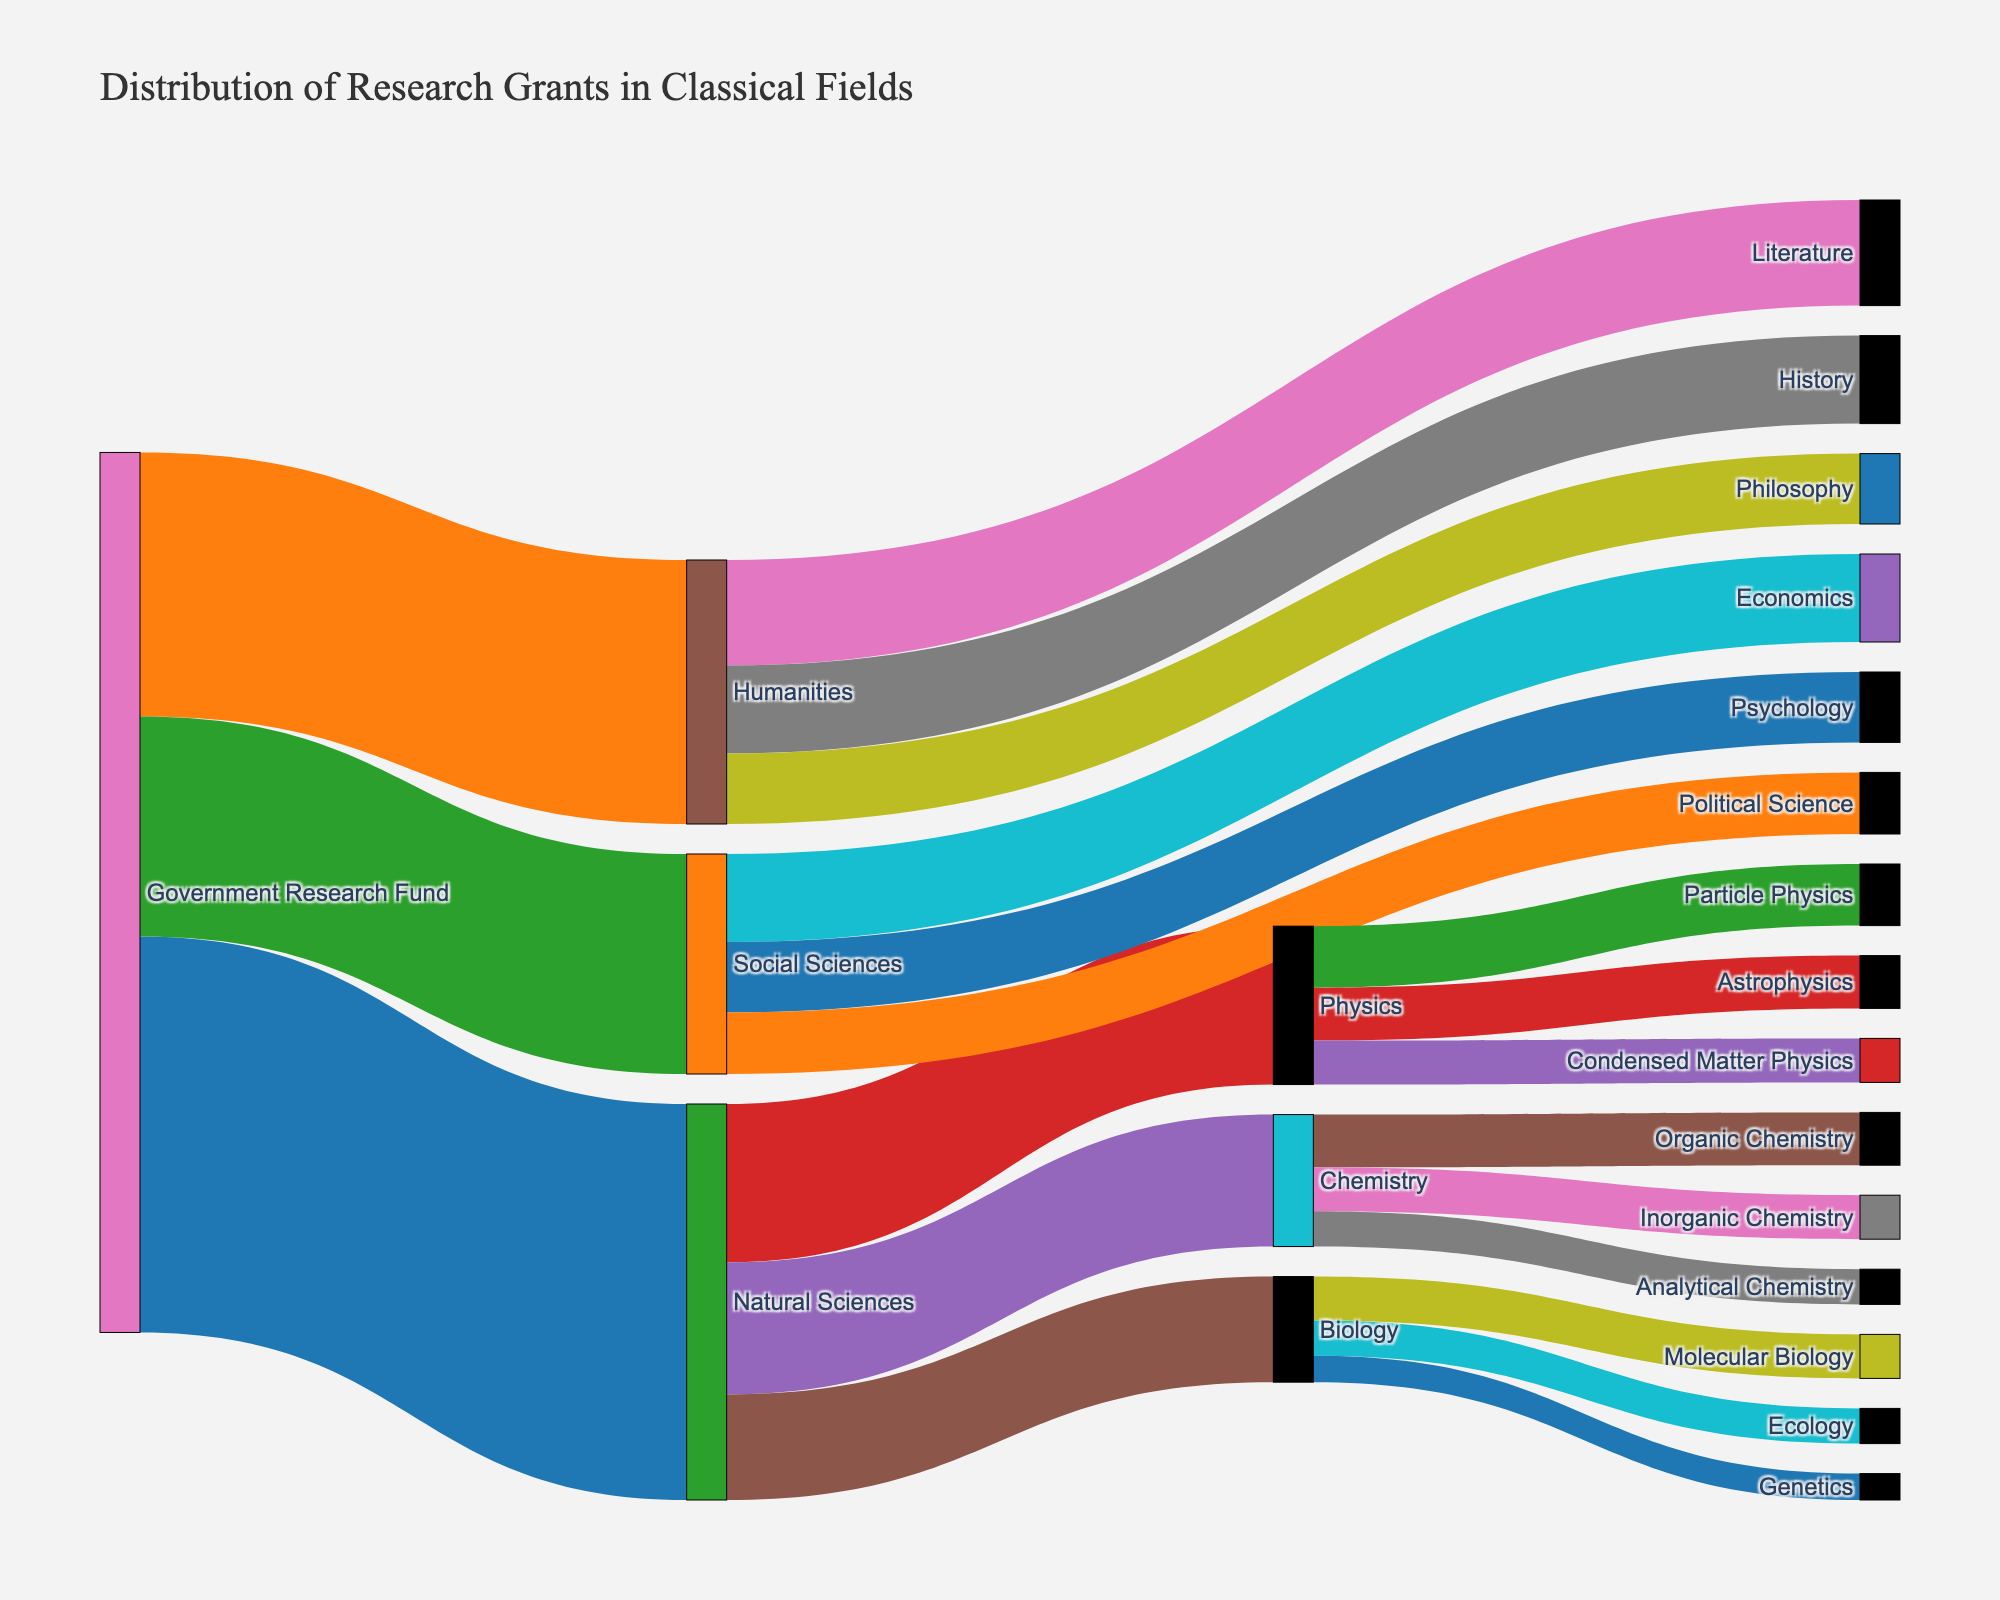What is the title of the figure? The title of the figure is displayed prominently at the top of the diagram. It reads "Distribution of Research Grants in Classical Fields".
Answer: Distribution of Research Grants in Classical Fields How many total research grants are allocated to the Natural Sciences? By following the flow from "Government Research Fund" to "Natural Sciences" in the Sankey diagram, the value associated with this flow is 450.
Answer: 450 Are grants for Organic Chemistry higher, lower, or equal to those for Inorganic Chemistry? By looking at the values flowing to "Organic Chemistry" and "Inorganic Chemistry" from "Chemistry", we see that Organic Chemistry has 60, while Inorganic Chemistry has 50. Hence, grants for Organic Chemistry are higher.
Answer: Higher What is the total amount of research grants allocated to the field of Physics and its subfields? To determine this, add the values flowing into Physics from the Natural Sciences (180) and also add the values for its subfields (Particle Physics: 70, Astrophysics: 60, Condensed Matter Physics: 50). Total = 180 + 70 + 60 + 50 = 360.
Answer: 360 Which subfield within the Natural Sciences received the least funding? From the values flowing to the subfields of Natural Sciences, "Genetics" has the smallest value of 30.
Answer: Genetics How does the funding for Humanities compare to that for Social Sciences? The total value for grants flowing into Humanities (300) is higher than that for Social Sciences (250).
Answer: Humanities has higher funding What is the combined amount of grants received by Literature and History within the Humanities? Add the values flowing to Literature (120) and History (100) from Humanities. Total = 120 + 100 = 220.
Answer: 220 Which subfield within Social Sciences received the most grants? By examining the values assigned to each subfield within Social Sciences, Economics received the highest funding of 100.
Answer: Economics Is the sum of grants for Chemistry's subfields greater than the total grants for Social Sciences? Total grants for Chemistry's subfields is calculated as Organic Chemistry (60) + Inorganic Chemistry (50) + Analytical Chemistry (40) = 150. Total grants for Social Sciences is 250. Therefore, 150 is less than 250.
Answer: No What is the overall proportion of grants received by Biology compared to the total grants for Natural Sciences? Grants for Biology are 120. Total grants for Natural Sciences are 450. The proportion is calculated as (120 / 450) * 100 = 26.67%.
Answer: 26.67% 